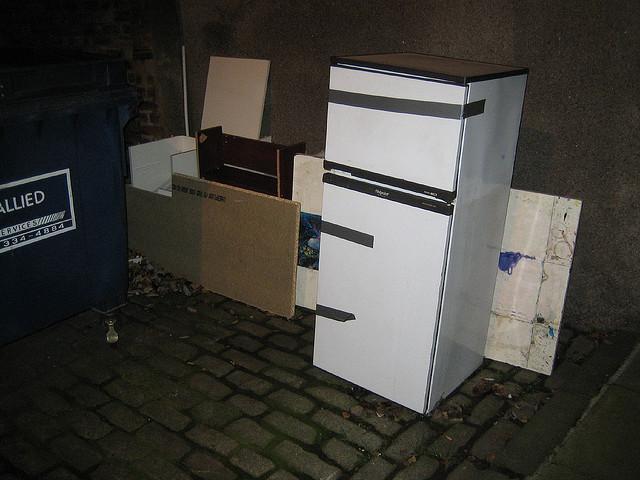How many black horse ?
Give a very brief answer. 0. 